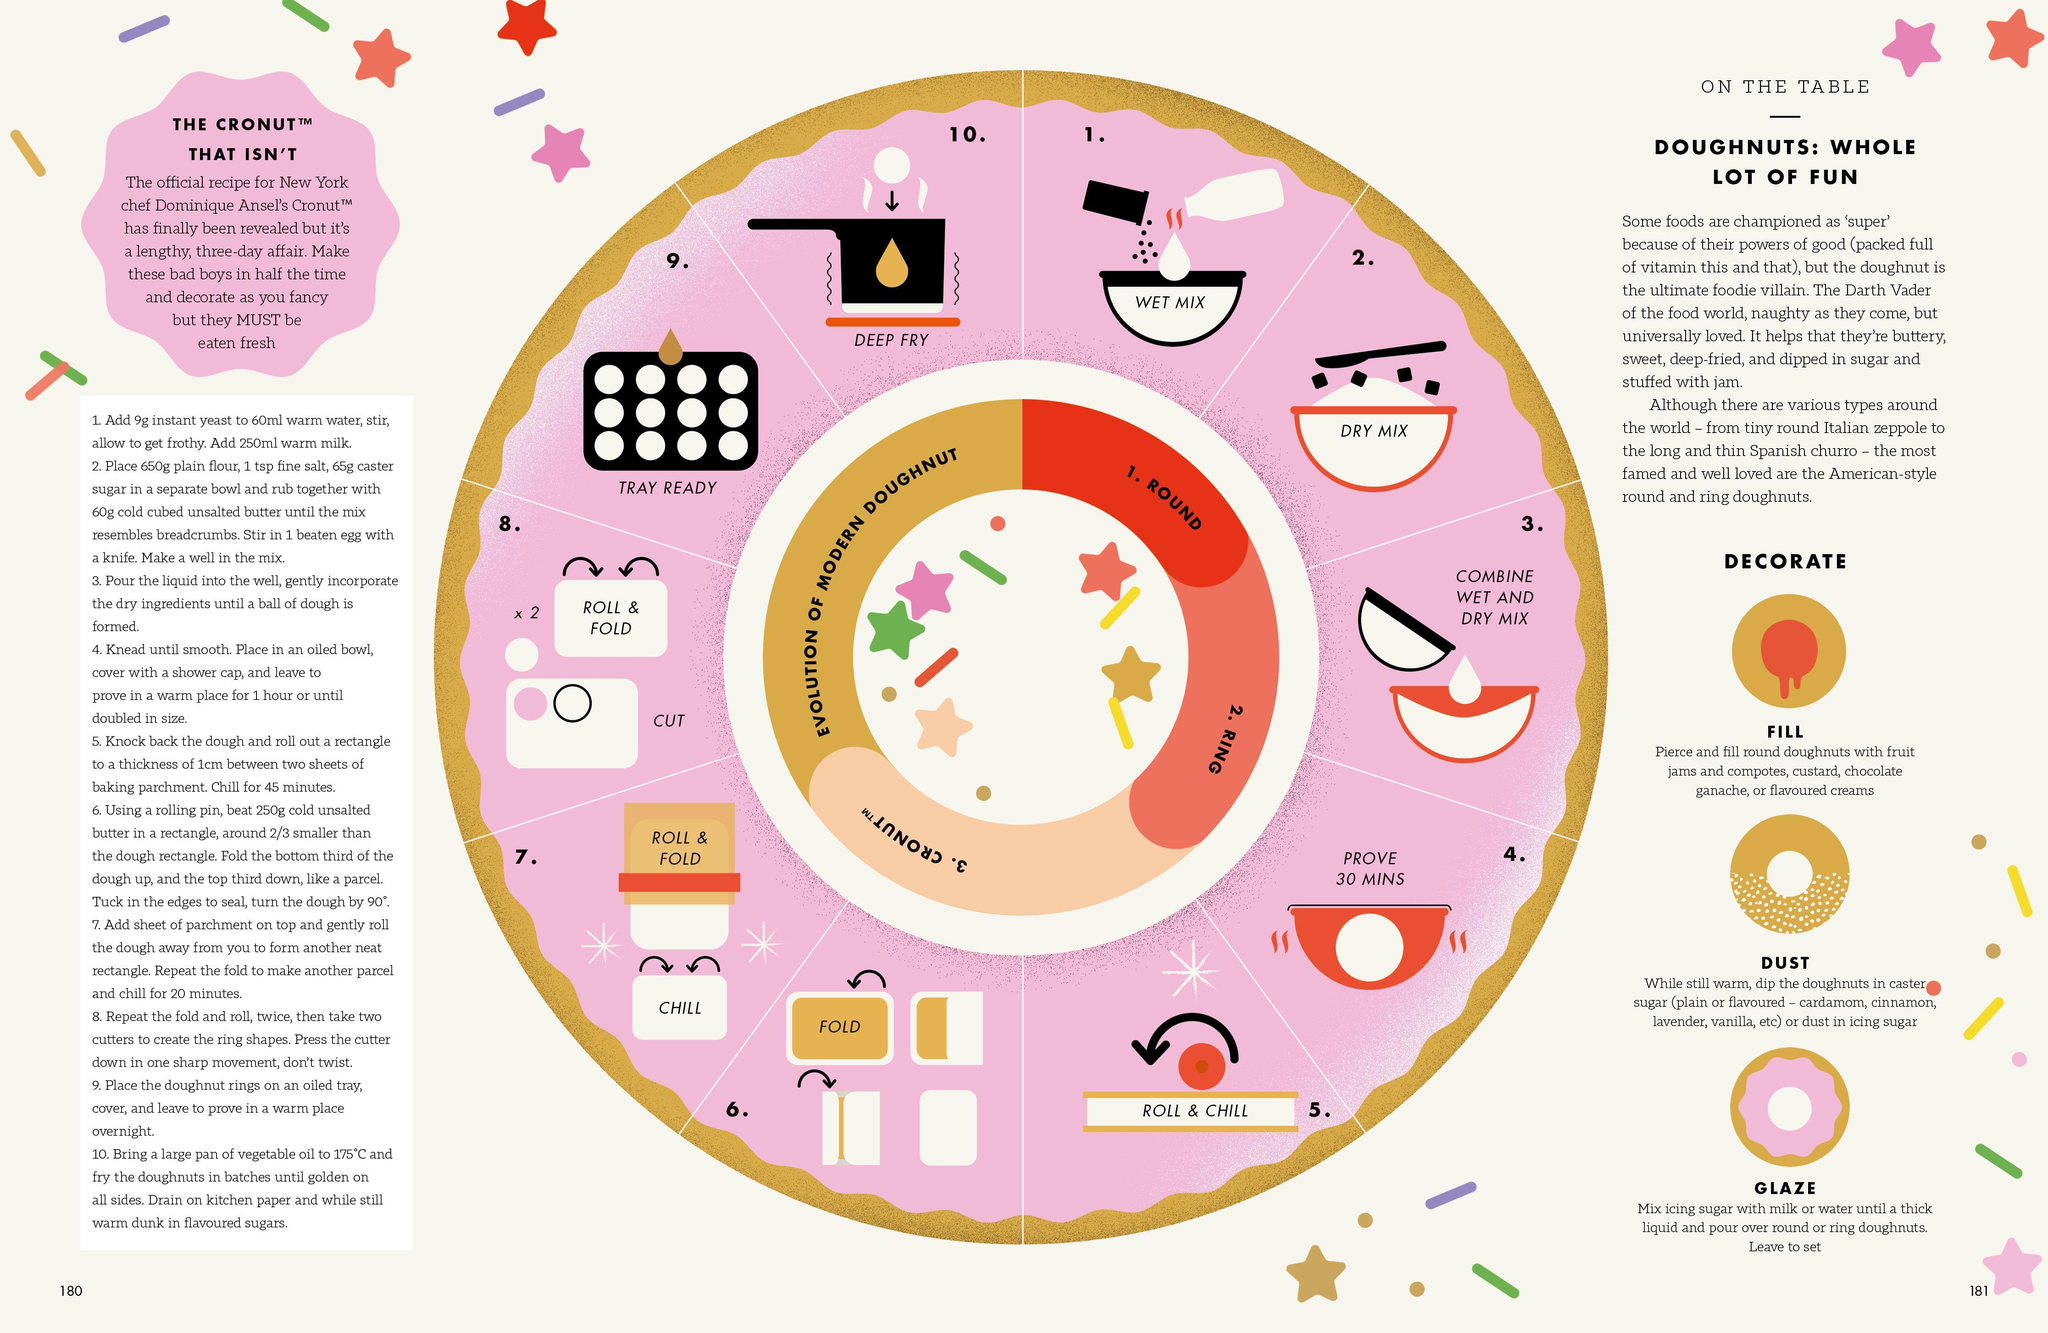Which are the three ways to decorate a doughnut ?
Answer the question with a short phrase. Fill, Dust, Glaze 